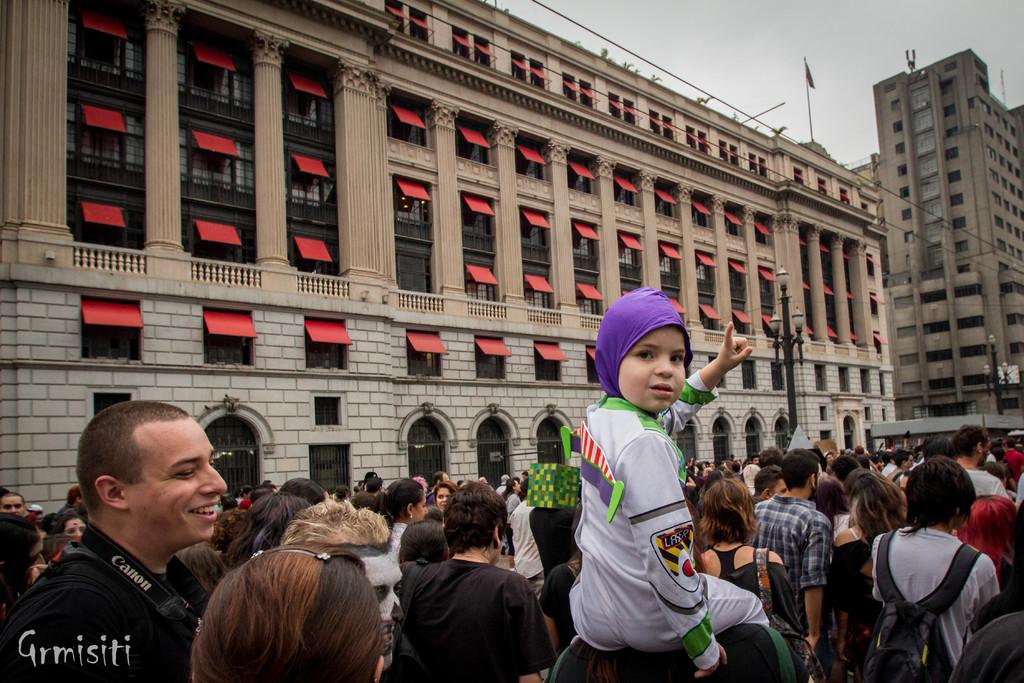How many people are in the group in the image? There is a group of people in the image, but the exact number is not specified. What are some people in the group carrying? Some people in the group are wearing backpacks. What can be seen in the background of the image? There are poles and lights, as well as buildings, visible in the background of the image. What type of feeling does the writer's son express in the image? There is no writer or son present in the image; it features a group of people and a background with poles, lights, and buildings. 